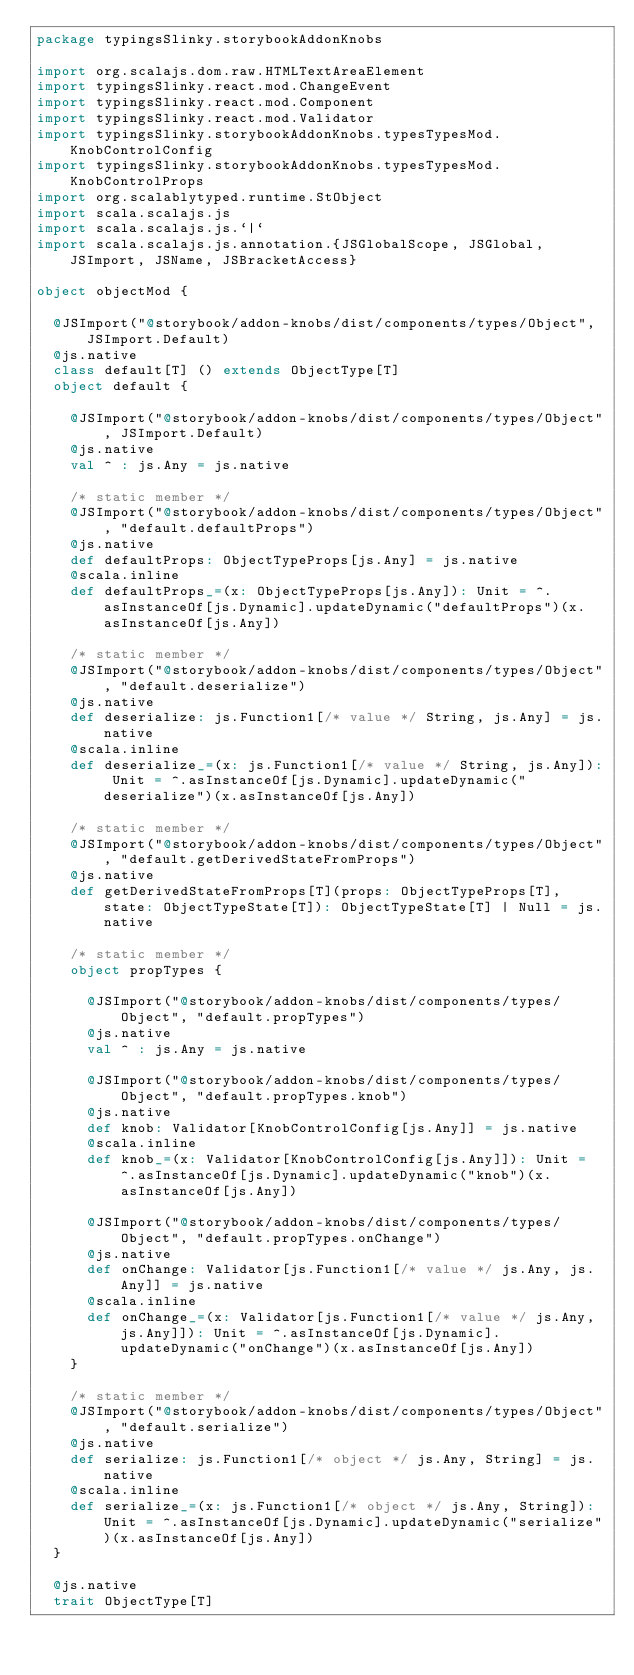<code> <loc_0><loc_0><loc_500><loc_500><_Scala_>package typingsSlinky.storybookAddonKnobs

import org.scalajs.dom.raw.HTMLTextAreaElement
import typingsSlinky.react.mod.ChangeEvent
import typingsSlinky.react.mod.Component
import typingsSlinky.react.mod.Validator
import typingsSlinky.storybookAddonKnobs.typesTypesMod.KnobControlConfig
import typingsSlinky.storybookAddonKnobs.typesTypesMod.KnobControlProps
import org.scalablytyped.runtime.StObject
import scala.scalajs.js
import scala.scalajs.js.`|`
import scala.scalajs.js.annotation.{JSGlobalScope, JSGlobal, JSImport, JSName, JSBracketAccess}

object objectMod {
  
  @JSImport("@storybook/addon-knobs/dist/components/types/Object", JSImport.Default)
  @js.native
  class default[T] () extends ObjectType[T]
  object default {
    
    @JSImport("@storybook/addon-knobs/dist/components/types/Object", JSImport.Default)
    @js.native
    val ^ : js.Any = js.native
    
    /* static member */
    @JSImport("@storybook/addon-knobs/dist/components/types/Object", "default.defaultProps")
    @js.native
    def defaultProps: ObjectTypeProps[js.Any] = js.native
    @scala.inline
    def defaultProps_=(x: ObjectTypeProps[js.Any]): Unit = ^.asInstanceOf[js.Dynamic].updateDynamic("defaultProps")(x.asInstanceOf[js.Any])
    
    /* static member */
    @JSImport("@storybook/addon-knobs/dist/components/types/Object", "default.deserialize")
    @js.native
    def deserialize: js.Function1[/* value */ String, js.Any] = js.native
    @scala.inline
    def deserialize_=(x: js.Function1[/* value */ String, js.Any]): Unit = ^.asInstanceOf[js.Dynamic].updateDynamic("deserialize")(x.asInstanceOf[js.Any])
    
    /* static member */
    @JSImport("@storybook/addon-knobs/dist/components/types/Object", "default.getDerivedStateFromProps")
    @js.native
    def getDerivedStateFromProps[T](props: ObjectTypeProps[T], state: ObjectTypeState[T]): ObjectTypeState[T] | Null = js.native
    
    /* static member */
    object propTypes {
      
      @JSImport("@storybook/addon-knobs/dist/components/types/Object", "default.propTypes")
      @js.native
      val ^ : js.Any = js.native
      
      @JSImport("@storybook/addon-knobs/dist/components/types/Object", "default.propTypes.knob")
      @js.native
      def knob: Validator[KnobControlConfig[js.Any]] = js.native
      @scala.inline
      def knob_=(x: Validator[KnobControlConfig[js.Any]]): Unit = ^.asInstanceOf[js.Dynamic].updateDynamic("knob")(x.asInstanceOf[js.Any])
      
      @JSImport("@storybook/addon-knobs/dist/components/types/Object", "default.propTypes.onChange")
      @js.native
      def onChange: Validator[js.Function1[/* value */ js.Any, js.Any]] = js.native
      @scala.inline
      def onChange_=(x: Validator[js.Function1[/* value */ js.Any, js.Any]]): Unit = ^.asInstanceOf[js.Dynamic].updateDynamic("onChange")(x.asInstanceOf[js.Any])
    }
    
    /* static member */
    @JSImport("@storybook/addon-knobs/dist/components/types/Object", "default.serialize")
    @js.native
    def serialize: js.Function1[/* object */ js.Any, String] = js.native
    @scala.inline
    def serialize_=(x: js.Function1[/* object */ js.Any, String]): Unit = ^.asInstanceOf[js.Dynamic].updateDynamic("serialize")(x.asInstanceOf[js.Any])
  }
  
  @js.native
  trait ObjectType[T]</code> 